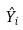Convert formula to latex. <formula><loc_0><loc_0><loc_500><loc_500>\hat { Y } _ { i }</formula> 